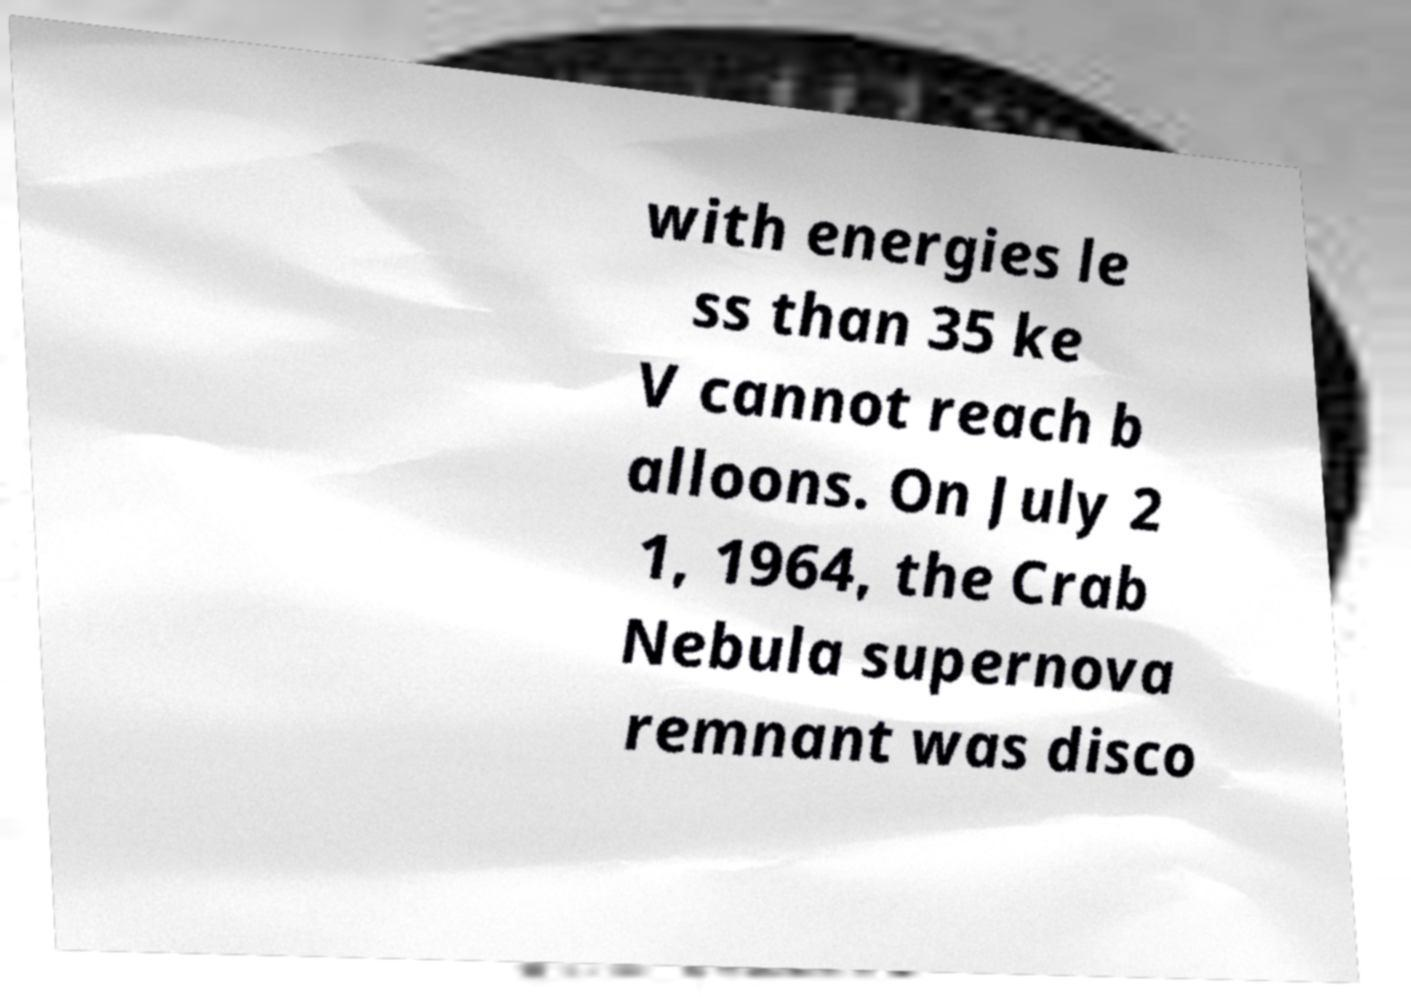Please identify and transcribe the text found in this image. with energies le ss than 35 ke V cannot reach b alloons. On July 2 1, 1964, the Crab Nebula supernova remnant was disco 